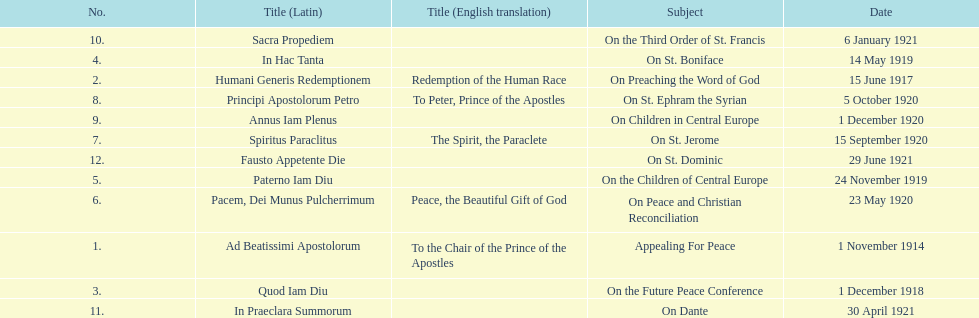What is the first english translation listed on the table? To the Chair of the Prince of the Apostles. 